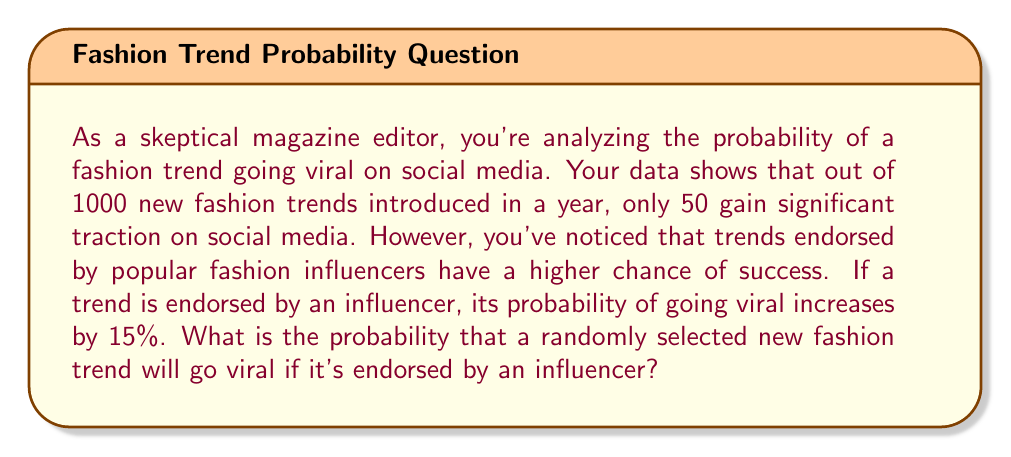Solve this math problem. Let's approach this step-by-step:

1) First, let's calculate the base probability of a trend going viral without influencer endorsement:

   $$P(\text{viral}) = \frac{\text{Number of viral trends}}{\text{Total number of trends}} = \frac{50}{1000} = 0.05 = 5\%$$

2) Now, we're told that influencer endorsement increases this probability by 15 percentage points. This means we need to add 0.15 to our base probability:

   $$P(\text{viral | endorsed}) = P(\text{viral}) + 0.15$$

3) Let's substitute our values:

   $$P(\text{viral | endorsed}) = 0.05 + 0.15 = 0.20$$

4) Convert to a percentage:

   $$0.20 \times 100\% = 20\%$$

Therefore, if a new fashion trend is endorsed by an influencer, it has a 20% chance of going viral on social media.
Answer: 20% 